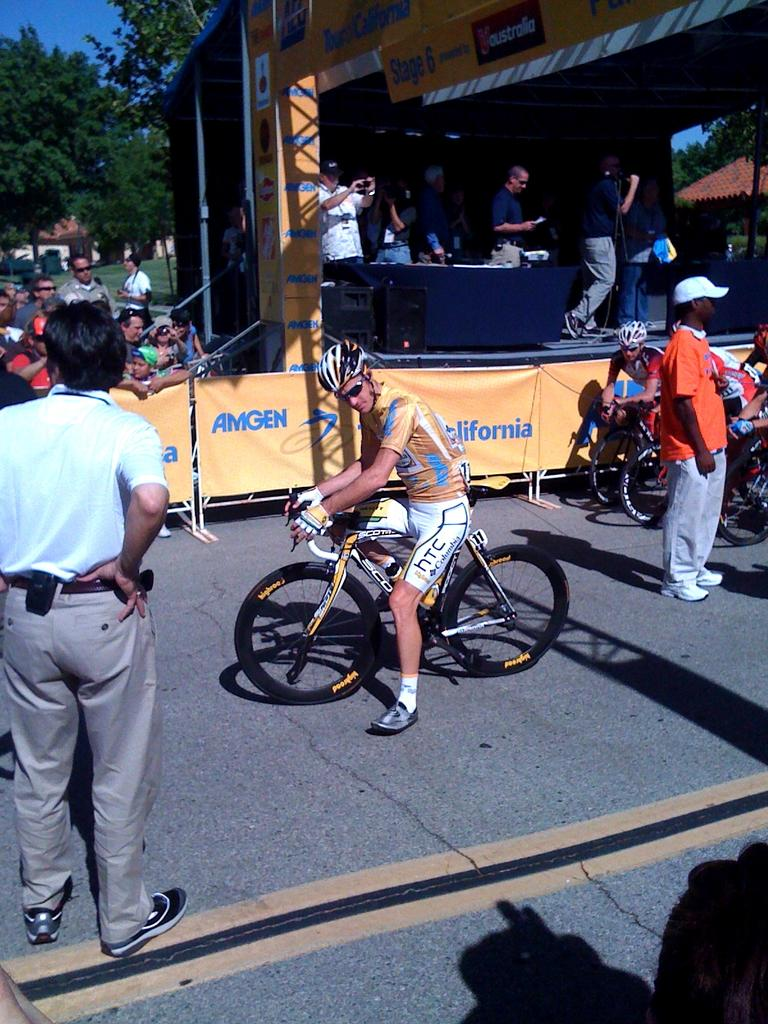Where was the image taken? The image is taken outdoors. What is the weather like in the image? It is sunny in the image. Can you describe the man in the image? There is a man in a yellow t-shirt, and he is riding a bicycle. What can be seen in the background of the image? In the background, there are banners, a group of people, trees, and the sky. Is there a flame visible on the man's bicycle in the image? No, there is no flame visible on the man's bicycle in the image. Can you see a kiss being exchanged between two people in the background? No, there is no kiss being exchanged between two people in the background of the image. 